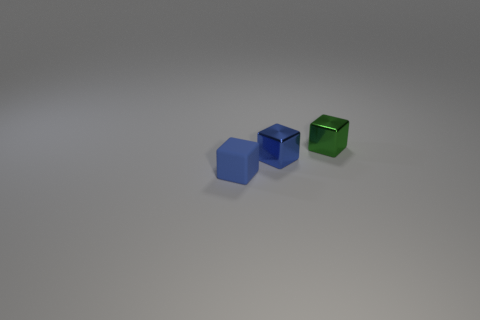There is a rubber thing; is its color the same as the tiny metallic cube on the left side of the green thing?
Ensure brevity in your answer.  Yes. What color is the matte thing?
Offer a very short reply. Blue. How many other objects are the same color as the rubber block?
Your response must be concise. 1. What material is the other blue thing that is the same shape as the small rubber object?
Keep it short and to the point. Metal. How many large red things are the same shape as the blue matte thing?
Ensure brevity in your answer.  0. The blue object that is to the left of the tiny blue cube behind the small blue matte block is what shape?
Provide a succinct answer. Cube. What size is the object that is both to the left of the tiny green shiny thing and behind the tiny blue matte block?
Offer a very short reply. Small. How many red metallic cubes have the same size as the blue metal block?
Offer a very short reply. 0. What number of things are behind the blue block that is behind the small matte object?
Your answer should be compact. 1. There is a shiny block left of the tiny green thing; is it the same color as the rubber object?
Make the answer very short. Yes. 